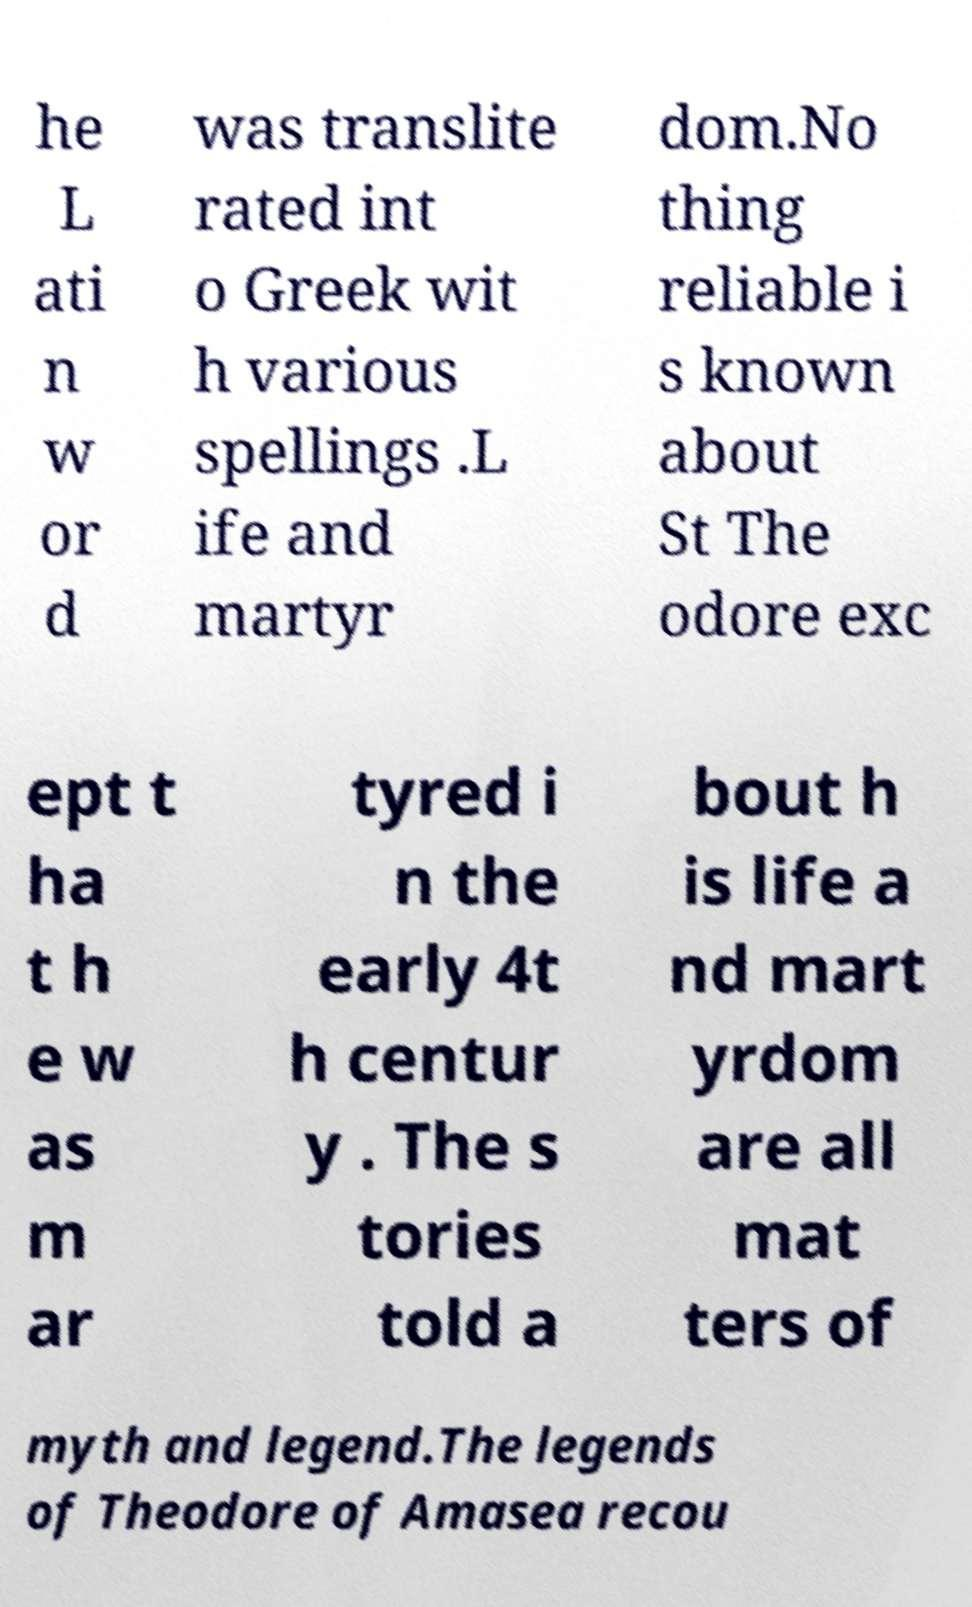Could you extract and type out the text from this image? he L ati n w or d was translite rated int o Greek wit h various spellings .L ife and martyr dom.No thing reliable i s known about St The odore exc ept t ha t h e w as m ar tyred i n the early 4t h centur y . The s tories told a bout h is life a nd mart yrdom are all mat ters of myth and legend.The legends of Theodore of Amasea recou 